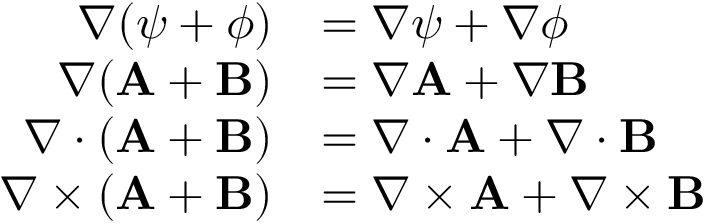Convert formula to latex. <formula><loc_0><loc_0><loc_500><loc_500>{ \begin{array} { r l } { \nabla ( \psi + \phi ) } & { = \nabla \psi + \nabla \phi } \\ { \nabla ( A + B ) } & { = \nabla A + \nabla B } \\ { \nabla \cdot ( A + B ) } & { = \nabla \cdot A + \nabla \cdot B } \\ { \nabla \times ( A + B ) } & { = \nabla \times A + \nabla \times B } \end{array} }</formula> 